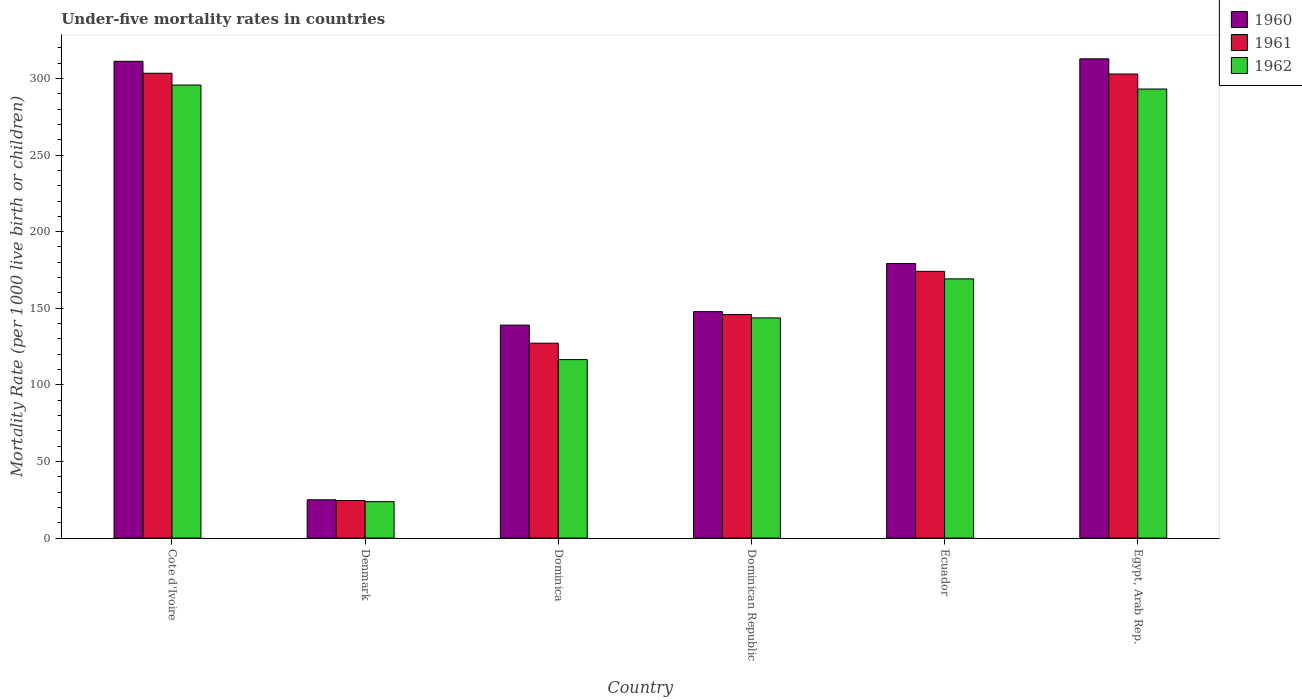What is the under-five mortality rate in 1962 in Egypt, Arab Rep.?
Make the answer very short. 293.1. Across all countries, what is the maximum under-five mortality rate in 1962?
Keep it short and to the point. 295.7. Across all countries, what is the minimum under-five mortality rate in 1960?
Your answer should be very brief. 25. In which country was the under-five mortality rate in 1960 maximum?
Your answer should be compact. Egypt, Arab Rep. What is the total under-five mortality rate in 1962 in the graph?
Your answer should be compact. 1042. What is the difference between the under-five mortality rate in 1961 in Dominican Republic and that in Ecuador?
Keep it short and to the point. -28.2. What is the difference between the under-five mortality rate in 1961 in Denmark and the under-five mortality rate in 1960 in Ecuador?
Offer a very short reply. -154.7. What is the average under-five mortality rate in 1962 per country?
Your response must be concise. 173.67. What is the difference between the under-five mortality rate of/in 1960 and under-five mortality rate of/in 1961 in Egypt, Arab Rep.?
Your answer should be very brief. 9.9. In how many countries, is the under-five mortality rate in 1961 greater than 150?
Give a very brief answer. 3. What is the ratio of the under-five mortality rate in 1960 in Dominica to that in Dominican Republic?
Make the answer very short. 0.94. Is the under-five mortality rate in 1961 in Cote d'Ivoire less than that in Denmark?
Offer a very short reply. No. Is the difference between the under-five mortality rate in 1960 in Denmark and Dominican Republic greater than the difference between the under-five mortality rate in 1961 in Denmark and Dominican Republic?
Keep it short and to the point. No. What is the difference between the highest and the second highest under-five mortality rate in 1960?
Ensure brevity in your answer.  133.6. What is the difference between the highest and the lowest under-five mortality rate in 1960?
Provide a short and direct response. 287.8. What does the 1st bar from the right in Dominica represents?
Give a very brief answer. 1962. How many countries are there in the graph?
Offer a terse response. 6. Are the values on the major ticks of Y-axis written in scientific E-notation?
Provide a succinct answer. No. How many legend labels are there?
Offer a terse response. 3. How are the legend labels stacked?
Make the answer very short. Vertical. What is the title of the graph?
Offer a terse response. Under-five mortality rates in countries. What is the label or title of the Y-axis?
Give a very brief answer. Mortality Rate (per 1000 live birth or children). What is the Mortality Rate (per 1000 live birth or children) of 1960 in Cote d'Ivoire?
Provide a short and direct response. 311.2. What is the Mortality Rate (per 1000 live birth or children) of 1961 in Cote d'Ivoire?
Ensure brevity in your answer.  303.4. What is the Mortality Rate (per 1000 live birth or children) in 1962 in Cote d'Ivoire?
Offer a terse response. 295.7. What is the Mortality Rate (per 1000 live birth or children) of 1960 in Denmark?
Provide a succinct answer. 25. What is the Mortality Rate (per 1000 live birth or children) in 1962 in Denmark?
Your response must be concise. 23.8. What is the Mortality Rate (per 1000 live birth or children) in 1960 in Dominica?
Your answer should be very brief. 139. What is the Mortality Rate (per 1000 live birth or children) in 1961 in Dominica?
Keep it short and to the point. 127.2. What is the Mortality Rate (per 1000 live birth or children) in 1962 in Dominica?
Provide a short and direct response. 116.5. What is the Mortality Rate (per 1000 live birth or children) in 1960 in Dominican Republic?
Keep it short and to the point. 147.8. What is the Mortality Rate (per 1000 live birth or children) in 1961 in Dominican Republic?
Offer a very short reply. 145.9. What is the Mortality Rate (per 1000 live birth or children) of 1962 in Dominican Republic?
Offer a very short reply. 143.7. What is the Mortality Rate (per 1000 live birth or children) in 1960 in Ecuador?
Your response must be concise. 179.2. What is the Mortality Rate (per 1000 live birth or children) in 1961 in Ecuador?
Your answer should be compact. 174.1. What is the Mortality Rate (per 1000 live birth or children) of 1962 in Ecuador?
Offer a very short reply. 169.2. What is the Mortality Rate (per 1000 live birth or children) of 1960 in Egypt, Arab Rep.?
Your response must be concise. 312.8. What is the Mortality Rate (per 1000 live birth or children) in 1961 in Egypt, Arab Rep.?
Your response must be concise. 302.9. What is the Mortality Rate (per 1000 live birth or children) in 1962 in Egypt, Arab Rep.?
Keep it short and to the point. 293.1. Across all countries, what is the maximum Mortality Rate (per 1000 live birth or children) in 1960?
Provide a succinct answer. 312.8. Across all countries, what is the maximum Mortality Rate (per 1000 live birth or children) in 1961?
Provide a short and direct response. 303.4. Across all countries, what is the maximum Mortality Rate (per 1000 live birth or children) in 1962?
Keep it short and to the point. 295.7. Across all countries, what is the minimum Mortality Rate (per 1000 live birth or children) of 1960?
Offer a very short reply. 25. Across all countries, what is the minimum Mortality Rate (per 1000 live birth or children) of 1962?
Your response must be concise. 23.8. What is the total Mortality Rate (per 1000 live birth or children) in 1960 in the graph?
Keep it short and to the point. 1115. What is the total Mortality Rate (per 1000 live birth or children) in 1961 in the graph?
Your answer should be very brief. 1078. What is the total Mortality Rate (per 1000 live birth or children) of 1962 in the graph?
Your answer should be very brief. 1042. What is the difference between the Mortality Rate (per 1000 live birth or children) in 1960 in Cote d'Ivoire and that in Denmark?
Offer a terse response. 286.2. What is the difference between the Mortality Rate (per 1000 live birth or children) of 1961 in Cote d'Ivoire and that in Denmark?
Ensure brevity in your answer.  278.9. What is the difference between the Mortality Rate (per 1000 live birth or children) of 1962 in Cote d'Ivoire and that in Denmark?
Your answer should be compact. 271.9. What is the difference between the Mortality Rate (per 1000 live birth or children) of 1960 in Cote d'Ivoire and that in Dominica?
Give a very brief answer. 172.2. What is the difference between the Mortality Rate (per 1000 live birth or children) of 1961 in Cote d'Ivoire and that in Dominica?
Provide a succinct answer. 176.2. What is the difference between the Mortality Rate (per 1000 live birth or children) in 1962 in Cote d'Ivoire and that in Dominica?
Offer a very short reply. 179.2. What is the difference between the Mortality Rate (per 1000 live birth or children) in 1960 in Cote d'Ivoire and that in Dominican Republic?
Provide a short and direct response. 163.4. What is the difference between the Mortality Rate (per 1000 live birth or children) of 1961 in Cote d'Ivoire and that in Dominican Republic?
Make the answer very short. 157.5. What is the difference between the Mortality Rate (per 1000 live birth or children) of 1962 in Cote d'Ivoire and that in Dominican Republic?
Your answer should be very brief. 152. What is the difference between the Mortality Rate (per 1000 live birth or children) of 1960 in Cote d'Ivoire and that in Ecuador?
Ensure brevity in your answer.  132. What is the difference between the Mortality Rate (per 1000 live birth or children) in 1961 in Cote d'Ivoire and that in Ecuador?
Your response must be concise. 129.3. What is the difference between the Mortality Rate (per 1000 live birth or children) of 1962 in Cote d'Ivoire and that in Ecuador?
Give a very brief answer. 126.5. What is the difference between the Mortality Rate (per 1000 live birth or children) in 1960 in Cote d'Ivoire and that in Egypt, Arab Rep.?
Give a very brief answer. -1.6. What is the difference between the Mortality Rate (per 1000 live birth or children) of 1962 in Cote d'Ivoire and that in Egypt, Arab Rep.?
Make the answer very short. 2.6. What is the difference between the Mortality Rate (per 1000 live birth or children) of 1960 in Denmark and that in Dominica?
Provide a succinct answer. -114. What is the difference between the Mortality Rate (per 1000 live birth or children) of 1961 in Denmark and that in Dominica?
Offer a terse response. -102.7. What is the difference between the Mortality Rate (per 1000 live birth or children) of 1962 in Denmark and that in Dominica?
Keep it short and to the point. -92.7. What is the difference between the Mortality Rate (per 1000 live birth or children) of 1960 in Denmark and that in Dominican Republic?
Provide a succinct answer. -122.8. What is the difference between the Mortality Rate (per 1000 live birth or children) of 1961 in Denmark and that in Dominican Republic?
Make the answer very short. -121.4. What is the difference between the Mortality Rate (per 1000 live birth or children) of 1962 in Denmark and that in Dominican Republic?
Provide a short and direct response. -119.9. What is the difference between the Mortality Rate (per 1000 live birth or children) of 1960 in Denmark and that in Ecuador?
Provide a succinct answer. -154.2. What is the difference between the Mortality Rate (per 1000 live birth or children) in 1961 in Denmark and that in Ecuador?
Keep it short and to the point. -149.6. What is the difference between the Mortality Rate (per 1000 live birth or children) in 1962 in Denmark and that in Ecuador?
Your answer should be very brief. -145.4. What is the difference between the Mortality Rate (per 1000 live birth or children) in 1960 in Denmark and that in Egypt, Arab Rep.?
Offer a terse response. -287.8. What is the difference between the Mortality Rate (per 1000 live birth or children) of 1961 in Denmark and that in Egypt, Arab Rep.?
Your answer should be very brief. -278.4. What is the difference between the Mortality Rate (per 1000 live birth or children) of 1962 in Denmark and that in Egypt, Arab Rep.?
Your response must be concise. -269.3. What is the difference between the Mortality Rate (per 1000 live birth or children) of 1961 in Dominica and that in Dominican Republic?
Offer a very short reply. -18.7. What is the difference between the Mortality Rate (per 1000 live birth or children) in 1962 in Dominica and that in Dominican Republic?
Keep it short and to the point. -27.2. What is the difference between the Mortality Rate (per 1000 live birth or children) of 1960 in Dominica and that in Ecuador?
Your answer should be compact. -40.2. What is the difference between the Mortality Rate (per 1000 live birth or children) in 1961 in Dominica and that in Ecuador?
Provide a short and direct response. -46.9. What is the difference between the Mortality Rate (per 1000 live birth or children) in 1962 in Dominica and that in Ecuador?
Your response must be concise. -52.7. What is the difference between the Mortality Rate (per 1000 live birth or children) of 1960 in Dominica and that in Egypt, Arab Rep.?
Offer a terse response. -173.8. What is the difference between the Mortality Rate (per 1000 live birth or children) in 1961 in Dominica and that in Egypt, Arab Rep.?
Offer a very short reply. -175.7. What is the difference between the Mortality Rate (per 1000 live birth or children) in 1962 in Dominica and that in Egypt, Arab Rep.?
Provide a succinct answer. -176.6. What is the difference between the Mortality Rate (per 1000 live birth or children) of 1960 in Dominican Republic and that in Ecuador?
Provide a short and direct response. -31.4. What is the difference between the Mortality Rate (per 1000 live birth or children) of 1961 in Dominican Republic and that in Ecuador?
Make the answer very short. -28.2. What is the difference between the Mortality Rate (per 1000 live birth or children) of 1962 in Dominican Republic and that in Ecuador?
Make the answer very short. -25.5. What is the difference between the Mortality Rate (per 1000 live birth or children) in 1960 in Dominican Republic and that in Egypt, Arab Rep.?
Offer a terse response. -165. What is the difference between the Mortality Rate (per 1000 live birth or children) in 1961 in Dominican Republic and that in Egypt, Arab Rep.?
Keep it short and to the point. -157. What is the difference between the Mortality Rate (per 1000 live birth or children) of 1962 in Dominican Republic and that in Egypt, Arab Rep.?
Provide a succinct answer. -149.4. What is the difference between the Mortality Rate (per 1000 live birth or children) in 1960 in Ecuador and that in Egypt, Arab Rep.?
Provide a succinct answer. -133.6. What is the difference between the Mortality Rate (per 1000 live birth or children) in 1961 in Ecuador and that in Egypt, Arab Rep.?
Make the answer very short. -128.8. What is the difference between the Mortality Rate (per 1000 live birth or children) of 1962 in Ecuador and that in Egypt, Arab Rep.?
Make the answer very short. -123.9. What is the difference between the Mortality Rate (per 1000 live birth or children) of 1960 in Cote d'Ivoire and the Mortality Rate (per 1000 live birth or children) of 1961 in Denmark?
Make the answer very short. 286.7. What is the difference between the Mortality Rate (per 1000 live birth or children) of 1960 in Cote d'Ivoire and the Mortality Rate (per 1000 live birth or children) of 1962 in Denmark?
Offer a terse response. 287.4. What is the difference between the Mortality Rate (per 1000 live birth or children) of 1961 in Cote d'Ivoire and the Mortality Rate (per 1000 live birth or children) of 1962 in Denmark?
Your response must be concise. 279.6. What is the difference between the Mortality Rate (per 1000 live birth or children) of 1960 in Cote d'Ivoire and the Mortality Rate (per 1000 live birth or children) of 1961 in Dominica?
Provide a succinct answer. 184. What is the difference between the Mortality Rate (per 1000 live birth or children) in 1960 in Cote d'Ivoire and the Mortality Rate (per 1000 live birth or children) in 1962 in Dominica?
Provide a short and direct response. 194.7. What is the difference between the Mortality Rate (per 1000 live birth or children) in 1961 in Cote d'Ivoire and the Mortality Rate (per 1000 live birth or children) in 1962 in Dominica?
Keep it short and to the point. 186.9. What is the difference between the Mortality Rate (per 1000 live birth or children) in 1960 in Cote d'Ivoire and the Mortality Rate (per 1000 live birth or children) in 1961 in Dominican Republic?
Ensure brevity in your answer.  165.3. What is the difference between the Mortality Rate (per 1000 live birth or children) in 1960 in Cote d'Ivoire and the Mortality Rate (per 1000 live birth or children) in 1962 in Dominican Republic?
Provide a short and direct response. 167.5. What is the difference between the Mortality Rate (per 1000 live birth or children) of 1961 in Cote d'Ivoire and the Mortality Rate (per 1000 live birth or children) of 1962 in Dominican Republic?
Provide a succinct answer. 159.7. What is the difference between the Mortality Rate (per 1000 live birth or children) of 1960 in Cote d'Ivoire and the Mortality Rate (per 1000 live birth or children) of 1961 in Ecuador?
Provide a succinct answer. 137.1. What is the difference between the Mortality Rate (per 1000 live birth or children) of 1960 in Cote d'Ivoire and the Mortality Rate (per 1000 live birth or children) of 1962 in Ecuador?
Offer a terse response. 142. What is the difference between the Mortality Rate (per 1000 live birth or children) of 1961 in Cote d'Ivoire and the Mortality Rate (per 1000 live birth or children) of 1962 in Ecuador?
Provide a short and direct response. 134.2. What is the difference between the Mortality Rate (per 1000 live birth or children) in 1960 in Cote d'Ivoire and the Mortality Rate (per 1000 live birth or children) in 1961 in Egypt, Arab Rep.?
Your answer should be very brief. 8.3. What is the difference between the Mortality Rate (per 1000 live birth or children) of 1960 in Cote d'Ivoire and the Mortality Rate (per 1000 live birth or children) of 1962 in Egypt, Arab Rep.?
Keep it short and to the point. 18.1. What is the difference between the Mortality Rate (per 1000 live birth or children) in 1961 in Cote d'Ivoire and the Mortality Rate (per 1000 live birth or children) in 1962 in Egypt, Arab Rep.?
Provide a succinct answer. 10.3. What is the difference between the Mortality Rate (per 1000 live birth or children) in 1960 in Denmark and the Mortality Rate (per 1000 live birth or children) in 1961 in Dominica?
Your answer should be very brief. -102.2. What is the difference between the Mortality Rate (per 1000 live birth or children) of 1960 in Denmark and the Mortality Rate (per 1000 live birth or children) of 1962 in Dominica?
Give a very brief answer. -91.5. What is the difference between the Mortality Rate (per 1000 live birth or children) of 1961 in Denmark and the Mortality Rate (per 1000 live birth or children) of 1962 in Dominica?
Your answer should be very brief. -92. What is the difference between the Mortality Rate (per 1000 live birth or children) of 1960 in Denmark and the Mortality Rate (per 1000 live birth or children) of 1961 in Dominican Republic?
Provide a short and direct response. -120.9. What is the difference between the Mortality Rate (per 1000 live birth or children) in 1960 in Denmark and the Mortality Rate (per 1000 live birth or children) in 1962 in Dominican Republic?
Give a very brief answer. -118.7. What is the difference between the Mortality Rate (per 1000 live birth or children) in 1961 in Denmark and the Mortality Rate (per 1000 live birth or children) in 1962 in Dominican Republic?
Make the answer very short. -119.2. What is the difference between the Mortality Rate (per 1000 live birth or children) of 1960 in Denmark and the Mortality Rate (per 1000 live birth or children) of 1961 in Ecuador?
Give a very brief answer. -149.1. What is the difference between the Mortality Rate (per 1000 live birth or children) in 1960 in Denmark and the Mortality Rate (per 1000 live birth or children) in 1962 in Ecuador?
Your response must be concise. -144.2. What is the difference between the Mortality Rate (per 1000 live birth or children) in 1961 in Denmark and the Mortality Rate (per 1000 live birth or children) in 1962 in Ecuador?
Give a very brief answer. -144.7. What is the difference between the Mortality Rate (per 1000 live birth or children) in 1960 in Denmark and the Mortality Rate (per 1000 live birth or children) in 1961 in Egypt, Arab Rep.?
Your response must be concise. -277.9. What is the difference between the Mortality Rate (per 1000 live birth or children) of 1960 in Denmark and the Mortality Rate (per 1000 live birth or children) of 1962 in Egypt, Arab Rep.?
Your response must be concise. -268.1. What is the difference between the Mortality Rate (per 1000 live birth or children) of 1961 in Denmark and the Mortality Rate (per 1000 live birth or children) of 1962 in Egypt, Arab Rep.?
Provide a succinct answer. -268.6. What is the difference between the Mortality Rate (per 1000 live birth or children) of 1960 in Dominica and the Mortality Rate (per 1000 live birth or children) of 1962 in Dominican Republic?
Offer a terse response. -4.7. What is the difference between the Mortality Rate (per 1000 live birth or children) of 1961 in Dominica and the Mortality Rate (per 1000 live birth or children) of 1962 in Dominican Republic?
Provide a succinct answer. -16.5. What is the difference between the Mortality Rate (per 1000 live birth or children) in 1960 in Dominica and the Mortality Rate (per 1000 live birth or children) in 1961 in Ecuador?
Provide a succinct answer. -35.1. What is the difference between the Mortality Rate (per 1000 live birth or children) in 1960 in Dominica and the Mortality Rate (per 1000 live birth or children) in 1962 in Ecuador?
Ensure brevity in your answer.  -30.2. What is the difference between the Mortality Rate (per 1000 live birth or children) of 1961 in Dominica and the Mortality Rate (per 1000 live birth or children) of 1962 in Ecuador?
Keep it short and to the point. -42. What is the difference between the Mortality Rate (per 1000 live birth or children) in 1960 in Dominica and the Mortality Rate (per 1000 live birth or children) in 1961 in Egypt, Arab Rep.?
Ensure brevity in your answer.  -163.9. What is the difference between the Mortality Rate (per 1000 live birth or children) of 1960 in Dominica and the Mortality Rate (per 1000 live birth or children) of 1962 in Egypt, Arab Rep.?
Offer a very short reply. -154.1. What is the difference between the Mortality Rate (per 1000 live birth or children) in 1961 in Dominica and the Mortality Rate (per 1000 live birth or children) in 1962 in Egypt, Arab Rep.?
Your response must be concise. -165.9. What is the difference between the Mortality Rate (per 1000 live birth or children) in 1960 in Dominican Republic and the Mortality Rate (per 1000 live birth or children) in 1961 in Ecuador?
Provide a succinct answer. -26.3. What is the difference between the Mortality Rate (per 1000 live birth or children) of 1960 in Dominican Republic and the Mortality Rate (per 1000 live birth or children) of 1962 in Ecuador?
Your response must be concise. -21.4. What is the difference between the Mortality Rate (per 1000 live birth or children) of 1961 in Dominican Republic and the Mortality Rate (per 1000 live birth or children) of 1962 in Ecuador?
Your answer should be very brief. -23.3. What is the difference between the Mortality Rate (per 1000 live birth or children) of 1960 in Dominican Republic and the Mortality Rate (per 1000 live birth or children) of 1961 in Egypt, Arab Rep.?
Provide a short and direct response. -155.1. What is the difference between the Mortality Rate (per 1000 live birth or children) of 1960 in Dominican Republic and the Mortality Rate (per 1000 live birth or children) of 1962 in Egypt, Arab Rep.?
Offer a very short reply. -145.3. What is the difference between the Mortality Rate (per 1000 live birth or children) in 1961 in Dominican Republic and the Mortality Rate (per 1000 live birth or children) in 1962 in Egypt, Arab Rep.?
Provide a short and direct response. -147.2. What is the difference between the Mortality Rate (per 1000 live birth or children) of 1960 in Ecuador and the Mortality Rate (per 1000 live birth or children) of 1961 in Egypt, Arab Rep.?
Give a very brief answer. -123.7. What is the difference between the Mortality Rate (per 1000 live birth or children) in 1960 in Ecuador and the Mortality Rate (per 1000 live birth or children) in 1962 in Egypt, Arab Rep.?
Your answer should be very brief. -113.9. What is the difference between the Mortality Rate (per 1000 live birth or children) of 1961 in Ecuador and the Mortality Rate (per 1000 live birth or children) of 1962 in Egypt, Arab Rep.?
Offer a terse response. -119. What is the average Mortality Rate (per 1000 live birth or children) in 1960 per country?
Provide a short and direct response. 185.83. What is the average Mortality Rate (per 1000 live birth or children) of 1961 per country?
Make the answer very short. 179.67. What is the average Mortality Rate (per 1000 live birth or children) in 1962 per country?
Ensure brevity in your answer.  173.67. What is the difference between the Mortality Rate (per 1000 live birth or children) in 1960 and Mortality Rate (per 1000 live birth or children) in 1962 in Cote d'Ivoire?
Your response must be concise. 15.5. What is the difference between the Mortality Rate (per 1000 live birth or children) of 1961 and Mortality Rate (per 1000 live birth or children) of 1962 in Cote d'Ivoire?
Make the answer very short. 7.7. What is the difference between the Mortality Rate (per 1000 live birth or children) of 1961 and Mortality Rate (per 1000 live birth or children) of 1962 in Denmark?
Offer a terse response. 0.7. What is the difference between the Mortality Rate (per 1000 live birth or children) in 1960 and Mortality Rate (per 1000 live birth or children) in 1962 in Dominica?
Give a very brief answer. 22.5. What is the difference between the Mortality Rate (per 1000 live birth or children) in 1960 and Mortality Rate (per 1000 live birth or children) in 1962 in Ecuador?
Your answer should be very brief. 10. What is the ratio of the Mortality Rate (per 1000 live birth or children) of 1960 in Cote d'Ivoire to that in Denmark?
Keep it short and to the point. 12.45. What is the ratio of the Mortality Rate (per 1000 live birth or children) in 1961 in Cote d'Ivoire to that in Denmark?
Give a very brief answer. 12.38. What is the ratio of the Mortality Rate (per 1000 live birth or children) of 1962 in Cote d'Ivoire to that in Denmark?
Provide a short and direct response. 12.42. What is the ratio of the Mortality Rate (per 1000 live birth or children) in 1960 in Cote d'Ivoire to that in Dominica?
Your response must be concise. 2.24. What is the ratio of the Mortality Rate (per 1000 live birth or children) in 1961 in Cote d'Ivoire to that in Dominica?
Your answer should be compact. 2.39. What is the ratio of the Mortality Rate (per 1000 live birth or children) in 1962 in Cote d'Ivoire to that in Dominica?
Your answer should be very brief. 2.54. What is the ratio of the Mortality Rate (per 1000 live birth or children) of 1960 in Cote d'Ivoire to that in Dominican Republic?
Your response must be concise. 2.11. What is the ratio of the Mortality Rate (per 1000 live birth or children) in 1961 in Cote d'Ivoire to that in Dominican Republic?
Your answer should be compact. 2.08. What is the ratio of the Mortality Rate (per 1000 live birth or children) in 1962 in Cote d'Ivoire to that in Dominican Republic?
Ensure brevity in your answer.  2.06. What is the ratio of the Mortality Rate (per 1000 live birth or children) in 1960 in Cote d'Ivoire to that in Ecuador?
Give a very brief answer. 1.74. What is the ratio of the Mortality Rate (per 1000 live birth or children) in 1961 in Cote d'Ivoire to that in Ecuador?
Offer a terse response. 1.74. What is the ratio of the Mortality Rate (per 1000 live birth or children) of 1962 in Cote d'Ivoire to that in Ecuador?
Provide a short and direct response. 1.75. What is the ratio of the Mortality Rate (per 1000 live birth or children) in 1960 in Cote d'Ivoire to that in Egypt, Arab Rep.?
Your answer should be very brief. 0.99. What is the ratio of the Mortality Rate (per 1000 live birth or children) of 1961 in Cote d'Ivoire to that in Egypt, Arab Rep.?
Offer a terse response. 1. What is the ratio of the Mortality Rate (per 1000 live birth or children) of 1962 in Cote d'Ivoire to that in Egypt, Arab Rep.?
Offer a very short reply. 1.01. What is the ratio of the Mortality Rate (per 1000 live birth or children) of 1960 in Denmark to that in Dominica?
Offer a very short reply. 0.18. What is the ratio of the Mortality Rate (per 1000 live birth or children) of 1961 in Denmark to that in Dominica?
Your answer should be very brief. 0.19. What is the ratio of the Mortality Rate (per 1000 live birth or children) of 1962 in Denmark to that in Dominica?
Keep it short and to the point. 0.2. What is the ratio of the Mortality Rate (per 1000 live birth or children) of 1960 in Denmark to that in Dominican Republic?
Give a very brief answer. 0.17. What is the ratio of the Mortality Rate (per 1000 live birth or children) of 1961 in Denmark to that in Dominican Republic?
Your response must be concise. 0.17. What is the ratio of the Mortality Rate (per 1000 live birth or children) of 1962 in Denmark to that in Dominican Republic?
Your answer should be very brief. 0.17. What is the ratio of the Mortality Rate (per 1000 live birth or children) of 1960 in Denmark to that in Ecuador?
Your answer should be very brief. 0.14. What is the ratio of the Mortality Rate (per 1000 live birth or children) in 1961 in Denmark to that in Ecuador?
Provide a succinct answer. 0.14. What is the ratio of the Mortality Rate (per 1000 live birth or children) of 1962 in Denmark to that in Ecuador?
Your response must be concise. 0.14. What is the ratio of the Mortality Rate (per 1000 live birth or children) of 1960 in Denmark to that in Egypt, Arab Rep.?
Give a very brief answer. 0.08. What is the ratio of the Mortality Rate (per 1000 live birth or children) in 1961 in Denmark to that in Egypt, Arab Rep.?
Provide a succinct answer. 0.08. What is the ratio of the Mortality Rate (per 1000 live birth or children) of 1962 in Denmark to that in Egypt, Arab Rep.?
Offer a very short reply. 0.08. What is the ratio of the Mortality Rate (per 1000 live birth or children) in 1960 in Dominica to that in Dominican Republic?
Your answer should be compact. 0.94. What is the ratio of the Mortality Rate (per 1000 live birth or children) in 1961 in Dominica to that in Dominican Republic?
Your answer should be compact. 0.87. What is the ratio of the Mortality Rate (per 1000 live birth or children) in 1962 in Dominica to that in Dominican Republic?
Your answer should be compact. 0.81. What is the ratio of the Mortality Rate (per 1000 live birth or children) in 1960 in Dominica to that in Ecuador?
Provide a short and direct response. 0.78. What is the ratio of the Mortality Rate (per 1000 live birth or children) in 1961 in Dominica to that in Ecuador?
Ensure brevity in your answer.  0.73. What is the ratio of the Mortality Rate (per 1000 live birth or children) in 1962 in Dominica to that in Ecuador?
Your answer should be very brief. 0.69. What is the ratio of the Mortality Rate (per 1000 live birth or children) of 1960 in Dominica to that in Egypt, Arab Rep.?
Provide a succinct answer. 0.44. What is the ratio of the Mortality Rate (per 1000 live birth or children) of 1961 in Dominica to that in Egypt, Arab Rep.?
Your answer should be very brief. 0.42. What is the ratio of the Mortality Rate (per 1000 live birth or children) in 1962 in Dominica to that in Egypt, Arab Rep.?
Provide a succinct answer. 0.4. What is the ratio of the Mortality Rate (per 1000 live birth or children) of 1960 in Dominican Republic to that in Ecuador?
Offer a very short reply. 0.82. What is the ratio of the Mortality Rate (per 1000 live birth or children) in 1961 in Dominican Republic to that in Ecuador?
Give a very brief answer. 0.84. What is the ratio of the Mortality Rate (per 1000 live birth or children) in 1962 in Dominican Republic to that in Ecuador?
Your response must be concise. 0.85. What is the ratio of the Mortality Rate (per 1000 live birth or children) of 1960 in Dominican Republic to that in Egypt, Arab Rep.?
Ensure brevity in your answer.  0.47. What is the ratio of the Mortality Rate (per 1000 live birth or children) of 1961 in Dominican Republic to that in Egypt, Arab Rep.?
Keep it short and to the point. 0.48. What is the ratio of the Mortality Rate (per 1000 live birth or children) in 1962 in Dominican Republic to that in Egypt, Arab Rep.?
Your response must be concise. 0.49. What is the ratio of the Mortality Rate (per 1000 live birth or children) of 1960 in Ecuador to that in Egypt, Arab Rep.?
Provide a succinct answer. 0.57. What is the ratio of the Mortality Rate (per 1000 live birth or children) of 1961 in Ecuador to that in Egypt, Arab Rep.?
Offer a very short reply. 0.57. What is the ratio of the Mortality Rate (per 1000 live birth or children) of 1962 in Ecuador to that in Egypt, Arab Rep.?
Offer a terse response. 0.58. What is the difference between the highest and the second highest Mortality Rate (per 1000 live birth or children) of 1961?
Your answer should be very brief. 0.5. What is the difference between the highest and the second highest Mortality Rate (per 1000 live birth or children) of 1962?
Your answer should be very brief. 2.6. What is the difference between the highest and the lowest Mortality Rate (per 1000 live birth or children) of 1960?
Your answer should be compact. 287.8. What is the difference between the highest and the lowest Mortality Rate (per 1000 live birth or children) of 1961?
Offer a very short reply. 278.9. What is the difference between the highest and the lowest Mortality Rate (per 1000 live birth or children) of 1962?
Your answer should be very brief. 271.9. 